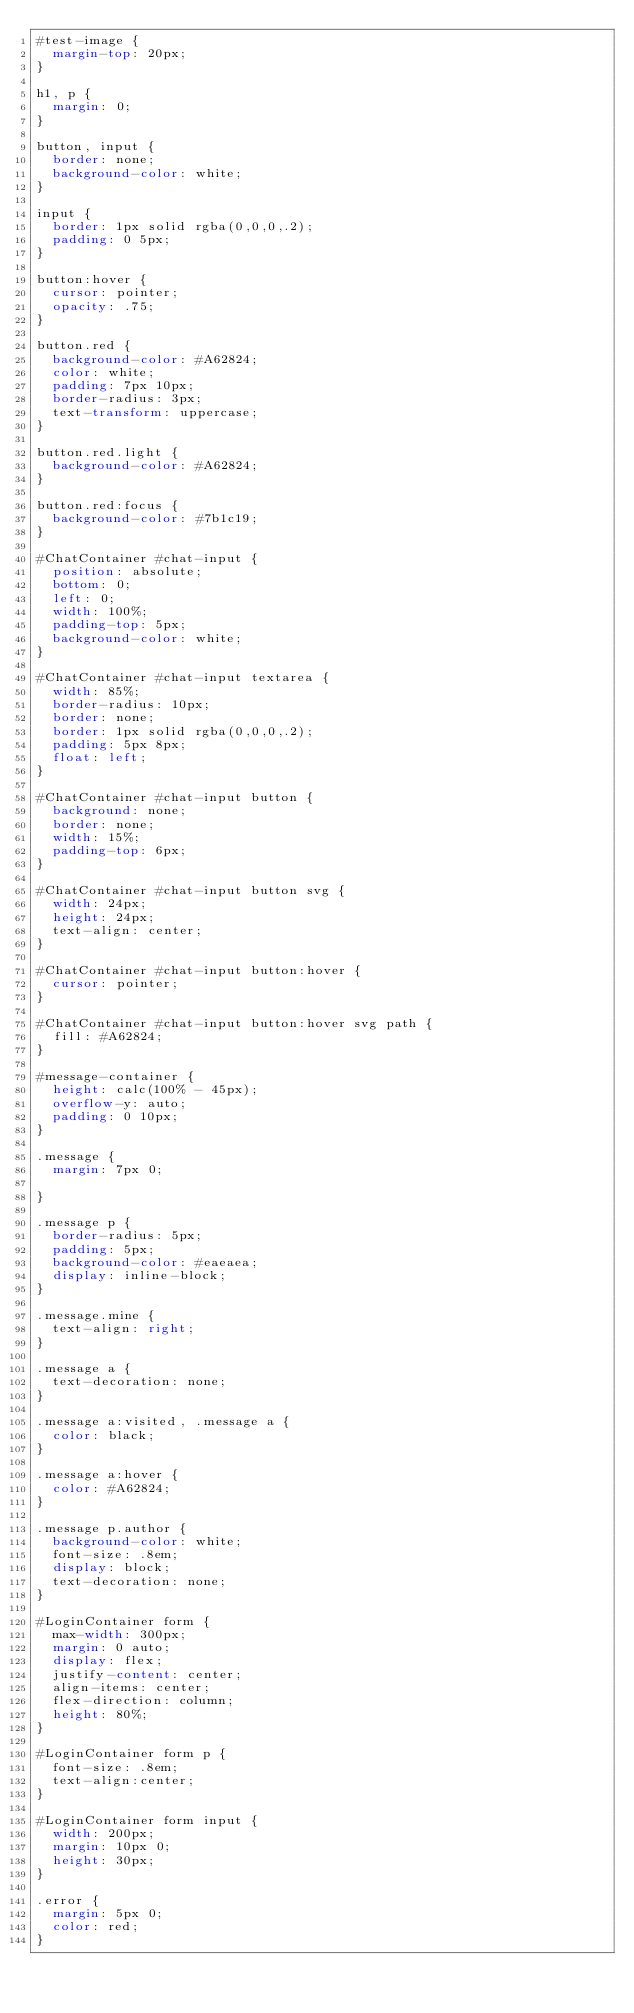<code> <loc_0><loc_0><loc_500><loc_500><_CSS_>#test-image {
  margin-top: 20px;
}

h1, p {
  margin: 0;
}

button, input {
  border: none;
  background-color: white;
}

input {
  border: 1px solid rgba(0,0,0,.2);
  padding: 0 5px;
}

button:hover {
  cursor: pointer;
  opacity: .75;
}

button.red {
  background-color: #A62824;
  color: white;
  padding: 7px 10px;
  border-radius: 3px;
  text-transform: uppercase;
}

button.red.light {
  background-color: #A62824;
}

button.red:focus {
  background-color: #7b1c19;
}

#ChatContainer #chat-input {
  position: absolute;
  bottom: 0;
  left: 0;
  width: 100%;
  padding-top: 5px;
  background-color: white;
}

#ChatContainer #chat-input textarea {
  width: 85%;
  border-radius: 10px;
  border: none;
  border: 1px solid rgba(0,0,0,.2);
  padding: 5px 8px;
  float: left;
}

#ChatContainer #chat-input button {
  background: none;
  border: none;
  width: 15%;
  padding-top: 6px;
}

#ChatContainer #chat-input button svg {
  width: 24px;
  height: 24px;
  text-align: center;
}

#ChatContainer #chat-input button:hover {
  cursor: pointer;
}

#ChatContainer #chat-input button:hover svg path {
  fill: #A62824;
}

#message-container {
  height: calc(100% - 45px);
  overflow-y: auto;
  padding: 0 10px;
}

.message {
  margin: 7px 0;

}

.message p {
  border-radius: 5px;
  padding: 5px;
  background-color: #eaeaea;
  display: inline-block;
}

.message.mine {
  text-align: right;
}

.message a {
  text-decoration: none;
}

.message a:visited, .message a {
  color: black;
}

.message a:hover {
  color: #A62824;
}

.message p.author {
  background-color: white;
  font-size: .8em;
  display: block;
  text-decoration: none;
}

#LoginContainer form {
  max-width: 300px;
  margin: 0 auto;
  display: flex;
  justify-content: center;
  align-items: center;
  flex-direction: column;
  height: 80%;
}

#LoginContainer form p {
  font-size: .8em;
  text-align:center;
}

#LoginContainer form input {
  width: 200px;
  margin: 10px 0;
  height: 30px;
}

.error {
  margin: 5px 0;
  color: red;
}
</code> 